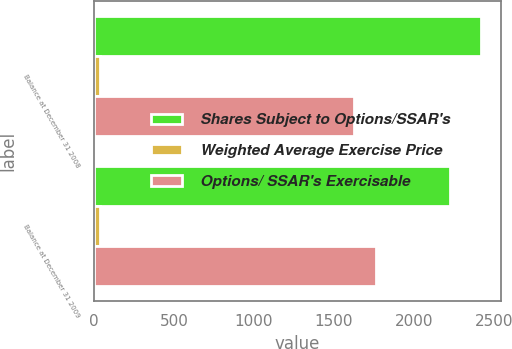Convert chart to OTSL. <chart><loc_0><loc_0><loc_500><loc_500><stacked_bar_chart><ecel><fcel>Balance at December 31 2008<fcel>Balance at December 31 2009<nl><fcel>Shares Subject to Options/SSAR's<fcel>2422<fcel>2228<nl><fcel>Weighted Average Exercise Price<fcel>35.86<fcel>35.27<nl><fcel>Options/ SSAR's Exercisable<fcel>1625<fcel>1763<nl></chart> 